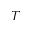Convert formula to latex. <formula><loc_0><loc_0><loc_500><loc_500>T</formula> 